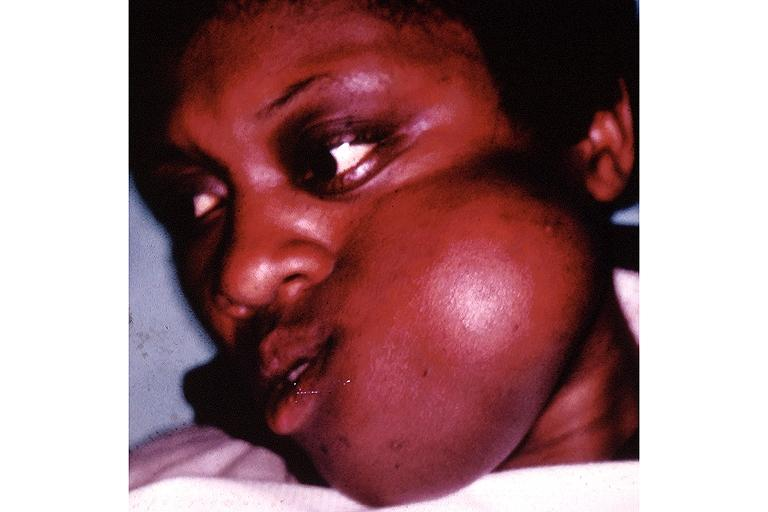does cryptosporidia show fibrous dysplasia?
Answer the question using a single word or phrase. No 